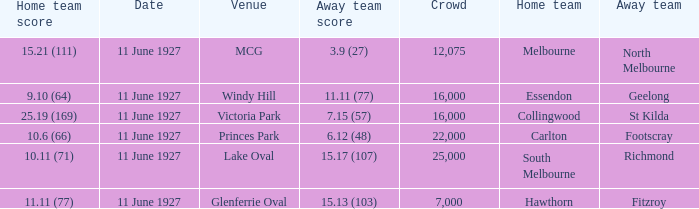How many people were present in a total of every crowd at the MCG venue? 12075.0. 